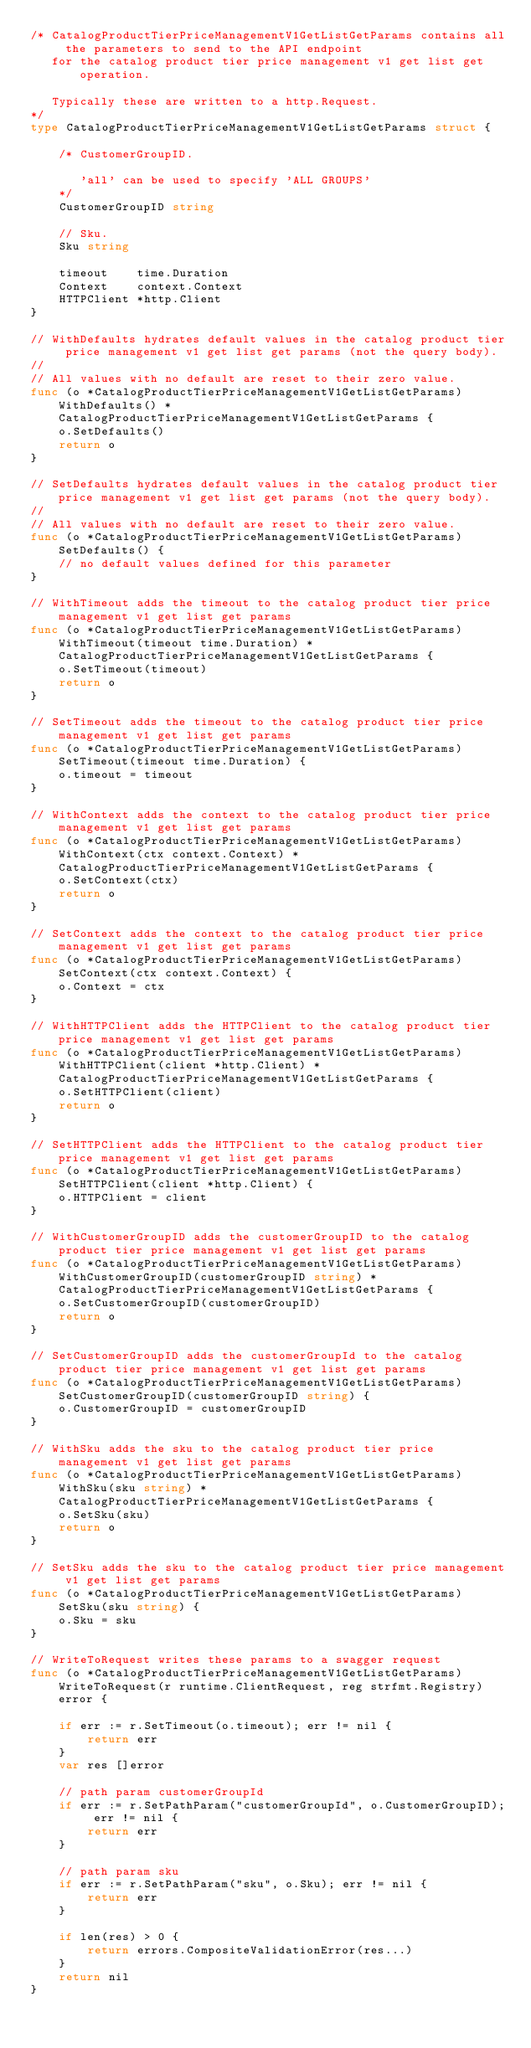Convert code to text. <code><loc_0><loc_0><loc_500><loc_500><_Go_>/* CatalogProductTierPriceManagementV1GetListGetParams contains all the parameters to send to the API endpoint
   for the catalog product tier price management v1 get list get operation.

   Typically these are written to a http.Request.
*/
type CatalogProductTierPriceManagementV1GetListGetParams struct {

	/* CustomerGroupID.

	   'all' can be used to specify 'ALL GROUPS'
	*/
	CustomerGroupID string

	// Sku.
	Sku string

	timeout    time.Duration
	Context    context.Context
	HTTPClient *http.Client
}

// WithDefaults hydrates default values in the catalog product tier price management v1 get list get params (not the query body).
//
// All values with no default are reset to their zero value.
func (o *CatalogProductTierPriceManagementV1GetListGetParams) WithDefaults() *CatalogProductTierPriceManagementV1GetListGetParams {
	o.SetDefaults()
	return o
}

// SetDefaults hydrates default values in the catalog product tier price management v1 get list get params (not the query body).
//
// All values with no default are reset to their zero value.
func (o *CatalogProductTierPriceManagementV1GetListGetParams) SetDefaults() {
	// no default values defined for this parameter
}

// WithTimeout adds the timeout to the catalog product tier price management v1 get list get params
func (o *CatalogProductTierPriceManagementV1GetListGetParams) WithTimeout(timeout time.Duration) *CatalogProductTierPriceManagementV1GetListGetParams {
	o.SetTimeout(timeout)
	return o
}

// SetTimeout adds the timeout to the catalog product tier price management v1 get list get params
func (o *CatalogProductTierPriceManagementV1GetListGetParams) SetTimeout(timeout time.Duration) {
	o.timeout = timeout
}

// WithContext adds the context to the catalog product tier price management v1 get list get params
func (o *CatalogProductTierPriceManagementV1GetListGetParams) WithContext(ctx context.Context) *CatalogProductTierPriceManagementV1GetListGetParams {
	o.SetContext(ctx)
	return o
}

// SetContext adds the context to the catalog product tier price management v1 get list get params
func (o *CatalogProductTierPriceManagementV1GetListGetParams) SetContext(ctx context.Context) {
	o.Context = ctx
}

// WithHTTPClient adds the HTTPClient to the catalog product tier price management v1 get list get params
func (o *CatalogProductTierPriceManagementV1GetListGetParams) WithHTTPClient(client *http.Client) *CatalogProductTierPriceManagementV1GetListGetParams {
	o.SetHTTPClient(client)
	return o
}

// SetHTTPClient adds the HTTPClient to the catalog product tier price management v1 get list get params
func (o *CatalogProductTierPriceManagementV1GetListGetParams) SetHTTPClient(client *http.Client) {
	o.HTTPClient = client
}

// WithCustomerGroupID adds the customerGroupID to the catalog product tier price management v1 get list get params
func (o *CatalogProductTierPriceManagementV1GetListGetParams) WithCustomerGroupID(customerGroupID string) *CatalogProductTierPriceManagementV1GetListGetParams {
	o.SetCustomerGroupID(customerGroupID)
	return o
}

// SetCustomerGroupID adds the customerGroupId to the catalog product tier price management v1 get list get params
func (o *CatalogProductTierPriceManagementV1GetListGetParams) SetCustomerGroupID(customerGroupID string) {
	o.CustomerGroupID = customerGroupID
}

// WithSku adds the sku to the catalog product tier price management v1 get list get params
func (o *CatalogProductTierPriceManagementV1GetListGetParams) WithSku(sku string) *CatalogProductTierPriceManagementV1GetListGetParams {
	o.SetSku(sku)
	return o
}

// SetSku adds the sku to the catalog product tier price management v1 get list get params
func (o *CatalogProductTierPriceManagementV1GetListGetParams) SetSku(sku string) {
	o.Sku = sku
}

// WriteToRequest writes these params to a swagger request
func (o *CatalogProductTierPriceManagementV1GetListGetParams) WriteToRequest(r runtime.ClientRequest, reg strfmt.Registry) error {

	if err := r.SetTimeout(o.timeout); err != nil {
		return err
	}
	var res []error

	// path param customerGroupId
	if err := r.SetPathParam("customerGroupId", o.CustomerGroupID); err != nil {
		return err
	}

	// path param sku
	if err := r.SetPathParam("sku", o.Sku); err != nil {
		return err
	}

	if len(res) > 0 {
		return errors.CompositeValidationError(res...)
	}
	return nil
}
</code> 